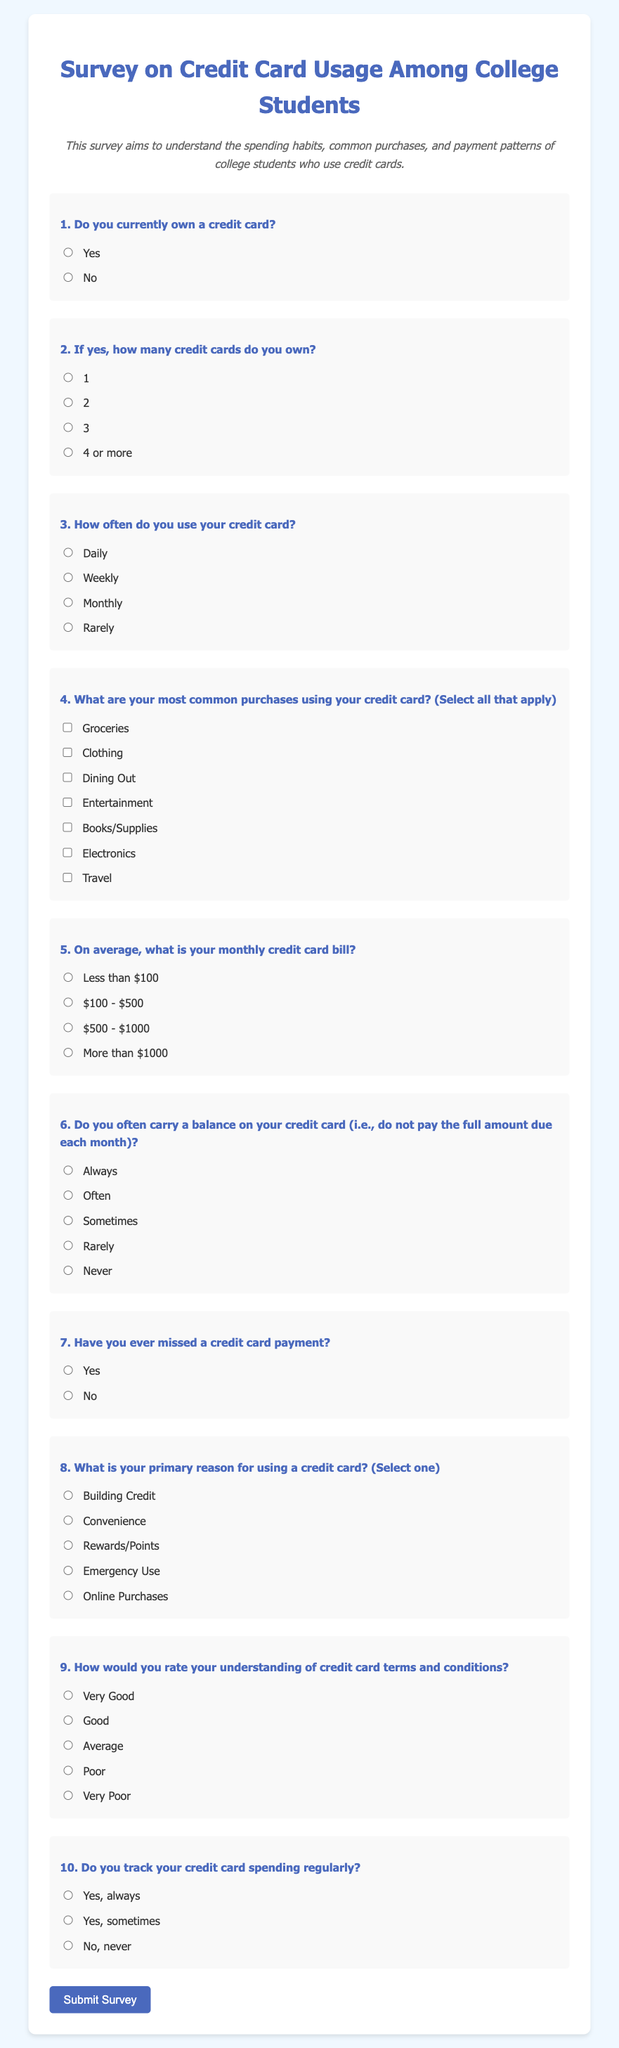What is the title of the survey? The title of the survey is presented at the top of the document, which is "Survey on Credit Card Usage Among College Students."
Answer: Survey on Credit Card Usage Among College Students How many questions are in the survey? The survey contains ten questions presented sequentially in the document.
Answer: 10 What is the primary reason students use a credit card based on the survey options? The survey includes a question that allows respondents to select a primary reason for using a credit card from several options.
Answer: Building Credit What is one of the options for monthly credit card bill ranges? The survey provides various options regarding the average monthly credit card bill amount, with specific ranges listed.
Answer: $100 - $500 What kind of question is number 6 in the survey? Question number 6 in the survey asks about the frequency of carrying a balance on the credit card and requires a specific type of response.
Answer: How often do you carry a balance on your credit card? What types of purchases can respondents select in question 4? Question 4 offers a range of purchase categories respondents can select as their most common credit card purchases, including multiple options.
Answer: Groceries, Clothing, Dining Out, Entertainment, Books/Supplies, Electronics, Travel Which demographic is the focus of this survey? The survey aims to gather information specifically from a certain group of individuals regarding their credit card usage.
Answer: College Students Do the survey questions allow multiple answers? Some questions in the survey are designed to allow respondents to select one answer, while others allow multiple selections, depending on the question format.
Answer: Yes How does the survey instruct participants to submit their responses? The survey document contains a specific button labeled for participants to finalize and send their answers after completion.
Answer: Submit Survey 